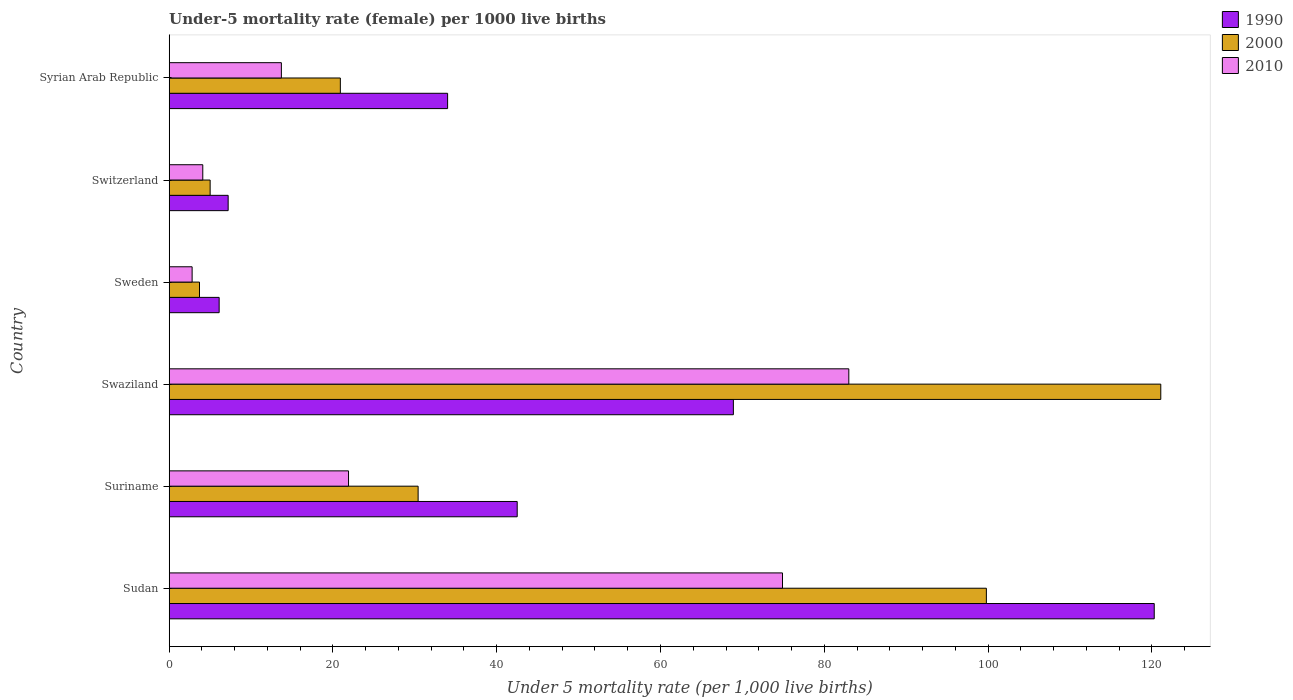How many different coloured bars are there?
Offer a terse response. 3. How many groups of bars are there?
Offer a terse response. 6. Are the number of bars per tick equal to the number of legend labels?
Offer a terse response. Yes. How many bars are there on the 5th tick from the bottom?
Provide a succinct answer. 3. What is the label of the 5th group of bars from the top?
Provide a short and direct response. Suriname. In how many cases, is the number of bars for a given country not equal to the number of legend labels?
Provide a succinct answer. 0. What is the under-five mortality rate in 2000 in Syrian Arab Republic?
Your answer should be very brief. 20.9. Across all countries, what is the maximum under-five mortality rate in 2010?
Offer a very short reply. 83. Across all countries, what is the minimum under-five mortality rate in 2010?
Make the answer very short. 2.8. In which country was the under-five mortality rate in 1990 maximum?
Ensure brevity in your answer.  Sudan. In which country was the under-five mortality rate in 2010 minimum?
Your response must be concise. Sweden. What is the total under-five mortality rate in 2000 in the graph?
Your answer should be compact. 280.9. What is the difference between the under-five mortality rate in 1990 in Sudan and that in Switzerland?
Ensure brevity in your answer.  113.1. What is the difference between the under-five mortality rate in 2000 in Syrian Arab Republic and the under-five mortality rate in 2010 in Swaziland?
Keep it short and to the point. -62.1. What is the average under-five mortality rate in 1990 per country?
Provide a short and direct response. 46.5. What is the difference between the under-five mortality rate in 2010 and under-five mortality rate in 1990 in Swaziland?
Give a very brief answer. 14.1. In how many countries, is the under-five mortality rate in 2010 greater than 12 ?
Your answer should be very brief. 4. What is the ratio of the under-five mortality rate in 1990 in Sweden to that in Syrian Arab Republic?
Ensure brevity in your answer.  0.18. Is the under-five mortality rate in 2010 in Swaziland less than that in Sweden?
Your answer should be very brief. No. Is the difference between the under-five mortality rate in 2010 in Sudan and Sweden greater than the difference between the under-five mortality rate in 1990 in Sudan and Sweden?
Your response must be concise. No. What is the difference between the highest and the second highest under-five mortality rate in 2010?
Provide a short and direct response. 8.1. What is the difference between the highest and the lowest under-five mortality rate in 1990?
Ensure brevity in your answer.  114.2. What does the 1st bar from the top in Sweden represents?
Give a very brief answer. 2010. Are all the bars in the graph horizontal?
Keep it short and to the point. Yes. How many countries are there in the graph?
Your response must be concise. 6. What is the difference between two consecutive major ticks on the X-axis?
Offer a terse response. 20. Does the graph contain grids?
Your answer should be very brief. No. How many legend labels are there?
Offer a terse response. 3. How are the legend labels stacked?
Keep it short and to the point. Vertical. What is the title of the graph?
Give a very brief answer. Under-5 mortality rate (female) per 1000 live births. What is the label or title of the X-axis?
Make the answer very short. Under 5 mortality rate (per 1,0 live births). What is the Under 5 mortality rate (per 1,000 live births) in 1990 in Sudan?
Give a very brief answer. 120.3. What is the Under 5 mortality rate (per 1,000 live births) of 2000 in Sudan?
Provide a short and direct response. 99.8. What is the Under 5 mortality rate (per 1,000 live births) in 2010 in Sudan?
Give a very brief answer. 74.9. What is the Under 5 mortality rate (per 1,000 live births) in 1990 in Suriname?
Keep it short and to the point. 42.5. What is the Under 5 mortality rate (per 1,000 live births) in 2000 in Suriname?
Your answer should be very brief. 30.4. What is the Under 5 mortality rate (per 1,000 live births) of 2010 in Suriname?
Offer a terse response. 21.9. What is the Under 5 mortality rate (per 1,000 live births) in 1990 in Swaziland?
Make the answer very short. 68.9. What is the Under 5 mortality rate (per 1,000 live births) of 2000 in Swaziland?
Your response must be concise. 121.1. What is the Under 5 mortality rate (per 1,000 live births) in 2000 in Sweden?
Ensure brevity in your answer.  3.7. What is the Under 5 mortality rate (per 1,000 live births) of 2010 in Sweden?
Your answer should be compact. 2.8. What is the Under 5 mortality rate (per 1,000 live births) in 2000 in Switzerland?
Offer a very short reply. 5. What is the Under 5 mortality rate (per 1,000 live births) of 2000 in Syrian Arab Republic?
Your answer should be very brief. 20.9. What is the Under 5 mortality rate (per 1,000 live births) of 2010 in Syrian Arab Republic?
Keep it short and to the point. 13.7. Across all countries, what is the maximum Under 5 mortality rate (per 1,000 live births) of 1990?
Offer a very short reply. 120.3. Across all countries, what is the maximum Under 5 mortality rate (per 1,000 live births) of 2000?
Your answer should be compact. 121.1. Across all countries, what is the minimum Under 5 mortality rate (per 1,000 live births) in 1990?
Provide a short and direct response. 6.1. Across all countries, what is the minimum Under 5 mortality rate (per 1,000 live births) in 2000?
Make the answer very short. 3.7. Across all countries, what is the minimum Under 5 mortality rate (per 1,000 live births) of 2010?
Your answer should be compact. 2.8. What is the total Under 5 mortality rate (per 1,000 live births) of 1990 in the graph?
Offer a terse response. 279. What is the total Under 5 mortality rate (per 1,000 live births) in 2000 in the graph?
Your answer should be very brief. 280.9. What is the total Under 5 mortality rate (per 1,000 live births) in 2010 in the graph?
Provide a succinct answer. 200.4. What is the difference between the Under 5 mortality rate (per 1,000 live births) in 1990 in Sudan and that in Suriname?
Offer a terse response. 77.8. What is the difference between the Under 5 mortality rate (per 1,000 live births) in 2000 in Sudan and that in Suriname?
Provide a short and direct response. 69.4. What is the difference between the Under 5 mortality rate (per 1,000 live births) of 2010 in Sudan and that in Suriname?
Provide a succinct answer. 53. What is the difference between the Under 5 mortality rate (per 1,000 live births) in 1990 in Sudan and that in Swaziland?
Provide a short and direct response. 51.4. What is the difference between the Under 5 mortality rate (per 1,000 live births) of 2000 in Sudan and that in Swaziland?
Offer a terse response. -21.3. What is the difference between the Under 5 mortality rate (per 1,000 live births) in 1990 in Sudan and that in Sweden?
Give a very brief answer. 114.2. What is the difference between the Under 5 mortality rate (per 1,000 live births) in 2000 in Sudan and that in Sweden?
Offer a terse response. 96.1. What is the difference between the Under 5 mortality rate (per 1,000 live births) of 2010 in Sudan and that in Sweden?
Your response must be concise. 72.1. What is the difference between the Under 5 mortality rate (per 1,000 live births) of 1990 in Sudan and that in Switzerland?
Provide a succinct answer. 113.1. What is the difference between the Under 5 mortality rate (per 1,000 live births) of 2000 in Sudan and that in Switzerland?
Make the answer very short. 94.8. What is the difference between the Under 5 mortality rate (per 1,000 live births) in 2010 in Sudan and that in Switzerland?
Provide a succinct answer. 70.8. What is the difference between the Under 5 mortality rate (per 1,000 live births) in 1990 in Sudan and that in Syrian Arab Republic?
Ensure brevity in your answer.  86.3. What is the difference between the Under 5 mortality rate (per 1,000 live births) in 2000 in Sudan and that in Syrian Arab Republic?
Your answer should be very brief. 78.9. What is the difference between the Under 5 mortality rate (per 1,000 live births) of 2010 in Sudan and that in Syrian Arab Republic?
Provide a succinct answer. 61.2. What is the difference between the Under 5 mortality rate (per 1,000 live births) in 1990 in Suriname and that in Swaziland?
Provide a succinct answer. -26.4. What is the difference between the Under 5 mortality rate (per 1,000 live births) of 2000 in Suriname and that in Swaziland?
Make the answer very short. -90.7. What is the difference between the Under 5 mortality rate (per 1,000 live births) of 2010 in Suriname and that in Swaziland?
Make the answer very short. -61.1. What is the difference between the Under 5 mortality rate (per 1,000 live births) in 1990 in Suriname and that in Sweden?
Offer a very short reply. 36.4. What is the difference between the Under 5 mortality rate (per 1,000 live births) in 2000 in Suriname and that in Sweden?
Give a very brief answer. 26.7. What is the difference between the Under 5 mortality rate (per 1,000 live births) in 2010 in Suriname and that in Sweden?
Your answer should be compact. 19.1. What is the difference between the Under 5 mortality rate (per 1,000 live births) in 1990 in Suriname and that in Switzerland?
Keep it short and to the point. 35.3. What is the difference between the Under 5 mortality rate (per 1,000 live births) in 2000 in Suriname and that in Switzerland?
Your answer should be compact. 25.4. What is the difference between the Under 5 mortality rate (per 1,000 live births) in 2010 in Suriname and that in Switzerland?
Your response must be concise. 17.8. What is the difference between the Under 5 mortality rate (per 1,000 live births) in 1990 in Suriname and that in Syrian Arab Republic?
Your response must be concise. 8.5. What is the difference between the Under 5 mortality rate (per 1,000 live births) in 2000 in Suriname and that in Syrian Arab Republic?
Your answer should be compact. 9.5. What is the difference between the Under 5 mortality rate (per 1,000 live births) of 2010 in Suriname and that in Syrian Arab Republic?
Make the answer very short. 8.2. What is the difference between the Under 5 mortality rate (per 1,000 live births) of 1990 in Swaziland and that in Sweden?
Give a very brief answer. 62.8. What is the difference between the Under 5 mortality rate (per 1,000 live births) of 2000 in Swaziland and that in Sweden?
Your answer should be very brief. 117.4. What is the difference between the Under 5 mortality rate (per 1,000 live births) of 2010 in Swaziland and that in Sweden?
Your response must be concise. 80.2. What is the difference between the Under 5 mortality rate (per 1,000 live births) in 1990 in Swaziland and that in Switzerland?
Your response must be concise. 61.7. What is the difference between the Under 5 mortality rate (per 1,000 live births) in 2000 in Swaziland and that in Switzerland?
Give a very brief answer. 116.1. What is the difference between the Under 5 mortality rate (per 1,000 live births) in 2010 in Swaziland and that in Switzerland?
Give a very brief answer. 78.9. What is the difference between the Under 5 mortality rate (per 1,000 live births) of 1990 in Swaziland and that in Syrian Arab Republic?
Your answer should be compact. 34.9. What is the difference between the Under 5 mortality rate (per 1,000 live births) in 2000 in Swaziland and that in Syrian Arab Republic?
Offer a very short reply. 100.2. What is the difference between the Under 5 mortality rate (per 1,000 live births) in 2010 in Swaziland and that in Syrian Arab Republic?
Keep it short and to the point. 69.3. What is the difference between the Under 5 mortality rate (per 1,000 live births) in 1990 in Sweden and that in Syrian Arab Republic?
Your response must be concise. -27.9. What is the difference between the Under 5 mortality rate (per 1,000 live births) in 2000 in Sweden and that in Syrian Arab Republic?
Give a very brief answer. -17.2. What is the difference between the Under 5 mortality rate (per 1,000 live births) of 2010 in Sweden and that in Syrian Arab Republic?
Your answer should be compact. -10.9. What is the difference between the Under 5 mortality rate (per 1,000 live births) in 1990 in Switzerland and that in Syrian Arab Republic?
Your response must be concise. -26.8. What is the difference between the Under 5 mortality rate (per 1,000 live births) in 2000 in Switzerland and that in Syrian Arab Republic?
Offer a terse response. -15.9. What is the difference between the Under 5 mortality rate (per 1,000 live births) of 2010 in Switzerland and that in Syrian Arab Republic?
Your response must be concise. -9.6. What is the difference between the Under 5 mortality rate (per 1,000 live births) of 1990 in Sudan and the Under 5 mortality rate (per 1,000 live births) of 2000 in Suriname?
Offer a very short reply. 89.9. What is the difference between the Under 5 mortality rate (per 1,000 live births) in 1990 in Sudan and the Under 5 mortality rate (per 1,000 live births) in 2010 in Suriname?
Make the answer very short. 98.4. What is the difference between the Under 5 mortality rate (per 1,000 live births) of 2000 in Sudan and the Under 5 mortality rate (per 1,000 live births) of 2010 in Suriname?
Keep it short and to the point. 77.9. What is the difference between the Under 5 mortality rate (per 1,000 live births) in 1990 in Sudan and the Under 5 mortality rate (per 1,000 live births) in 2000 in Swaziland?
Your answer should be compact. -0.8. What is the difference between the Under 5 mortality rate (per 1,000 live births) in 1990 in Sudan and the Under 5 mortality rate (per 1,000 live births) in 2010 in Swaziland?
Provide a short and direct response. 37.3. What is the difference between the Under 5 mortality rate (per 1,000 live births) in 1990 in Sudan and the Under 5 mortality rate (per 1,000 live births) in 2000 in Sweden?
Your answer should be compact. 116.6. What is the difference between the Under 5 mortality rate (per 1,000 live births) in 1990 in Sudan and the Under 5 mortality rate (per 1,000 live births) in 2010 in Sweden?
Give a very brief answer. 117.5. What is the difference between the Under 5 mortality rate (per 1,000 live births) in 2000 in Sudan and the Under 5 mortality rate (per 1,000 live births) in 2010 in Sweden?
Give a very brief answer. 97. What is the difference between the Under 5 mortality rate (per 1,000 live births) of 1990 in Sudan and the Under 5 mortality rate (per 1,000 live births) of 2000 in Switzerland?
Provide a short and direct response. 115.3. What is the difference between the Under 5 mortality rate (per 1,000 live births) in 1990 in Sudan and the Under 5 mortality rate (per 1,000 live births) in 2010 in Switzerland?
Provide a short and direct response. 116.2. What is the difference between the Under 5 mortality rate (per 1,000 live births) in 2000 in Sudan and the Under 5 mortality rate (per 1,000 live births) in 2010 in Switzerland?
Your answer should be very brief. 95.7. What is the difference between the Under 5 mortality rate (per 1,000 live births) in 1990 in Sudan and the Under 5 mortality rate (per 1,000 live births) in 2000 in Syrian Arab Republic?
Your answer should be compact. 99.4. What is the difference between the Under 5 mortality rate (per 1,000 live births) in 1990 in Sudan and the Under 5 mortality rate (per 1,000 live births) in 2010 in Syrian Arab Republic?
Your answer should be compact. 106.6. What is the difference between the Under 5 mortality rate (per 1,000 live births) of 2000 in Sudan and the Under 5 mortality rate (per 1,000 live births) of 2010 in Syrian Arab Republic?
Your response must be concise. 86.1. What is the difference between the Under 5 mortality rate (per 1,000 live births) of 1990 in Suriname and the Under 5 mortality rate (per 1,000 live births) of 2000 in Swaziland?
Your response must be concise. -78.6. What is the difference between the Under 5 mortality rate (per 1,000 live births) in 1990 in Suriname and the Under 5 mortality rate (per 1,000 live births) in 2010 in Swaziland?
Give a very brief answer. -40.5. What is the difference between the Under 5 mortality rate (per 1,000 live births) of 2000 in Suriname and the Under 5 mortality rate (per 1,000 live births) of 2010 in Swaziland?
Make the answer very short. -52.6. What is the difference between the Under 5 mortality rate (per 1,000 live births) in 1990 in Suriname and the Under 5 mortality rate (per 1,000 live births) in 2000 in Sweden?
Offer a terse response. 38.8. What is the difference between the Under 5 mortality rate (per 1,000 live births) in 1990 in Suriname and the Under 5 mortality rate (per 1,000 live births) in 2010 in Sweden?
Offer a terse response. 39.7. What is the difference between the Under 5 mortality rate (per 1,000 live births) of 2000 in Suriname and the Under 5 mortality rate (per 1,000 live births) of 2010 in Sweden?
Offer a terse response. 27.6. What is the difference between the Under 5 mortality rate (per 1,000 live births) of 1990 in Suriname and the Under 5 mortality rate (per 1,000 live births) of 2000 in Switzerland?
Provide a succinct answer. 37.5. What is the difference between the Under 5 mortality rate (per 1,000 live births) of 1990 in Suriname and the Under 5 mortality rate (per 1,000 live births) of 2010 in Switzerland?
Ensure brevity in your answer.  38.4. What is the difference between the Under 5 mortality rate (per 1,000 live births) in 2000 in Suriname and the Under 5 mortality rate (per 1,000 live births) in 2010 in Switzerland?
Keep it short and to the point. 26.3. What is the difference between the Under 5 mortality rate (per 1,000 live births) in 1990 in Suriname and the Under 5 mortality rate (per 1,000 live births) in 2000 in Syrian Arab Republic?
Provide a short and direct response. 21.6. What is the difference between the Under 5 mortality rate (per 1,000 live births) of 1990 in Suriname and the Under 5 mortality rate (per 1,000 live births) of 2010 in Syrian Arab Republic?
Your answer should be compact. 28.8. What is the difference between the Under 5 mortality rate (per 1,000 live births) in 2000 in Suriname and the Under 5 mortality rate (per 1,000 live births) in 2010 in Syrian Arab Republic?
Your answer should be very brief. 16.7. What is the difference between the Under 5 mortality rate (per 1,000 live births) in 1990 in Swaziland and the Under 5 mortality rate (per 1,000 live births) in 2000 in Sweden?
Provide a short and direct response. 65.2. What is the difference between the Under 5 mortality rate (per 1,000 live births) of 1990 in Swaziland and the Under 5 mortality rate (per 1,000 live births) of 2010 in Sweden?
Provide a short and direct response. 66.1. What is the difference between the Under 5 mortality rate (per 1,000 live births) in 2000 in Swaziland and the Under 5 mortality rate (per 1,000 live births) in 2010 in Sweden?
Your response must be concise. 118.3. What is the difference between the Under 5 mortality rate (per 1,000 live births) in 1990 in Swaziland and the Under 5 mortality rate (per 1,000 live births) in 2000 in Switzerland?
Provide a succinct answer. 63.9. What is the difference between the Under 5 mortality rate (per 1,000 live births) in 1990 in Swaziland and the Under 5 mortality rate (per 1,000 live births) in 2010 in Switzerland?
Provide a short and direct response. 64.8. What is the difference between the Under 5 mortality rate (per 1,000 live births) in 2000 in Swaziland and the Under 5 mortality rate (per 1,000 live births) in 2010 in Switzerland?
Keep it short and to the point. 117. What is the difference between the Under 5 mortality rate (per 1,000 live births) of 1990 in Swaziland and the Under 5 mortality rate (per 1,000 live births) of 2010 in Syrian Arab Republic?
Offer a terse response. 55.2. What is the difference between the Under 5 mortality rate (per 1,000 live births) in 2000 in Swaziland and the Under 5 mortality rate (per 1,000 live births) in 2010 in Syrian Arab Republic?
Provide a succinct answer. 107.4. What is the difference between the Under 5 mortality rate (per 1,000 live births) of 1990 in Sweden and the Under 5 mortality rate (per 1,000 live births) of 2000 in Switzerland?
Provide a short and direct response. 1.1. What is the difference between the Under 5 mortality rate (per 1,000 live births) in 2000 in Sweden and the Under 5 mortality rate (per 1,000 live births) in 2010 in Switzerland?
Offer a terse response. -0.4. What is the difference between the Under 5 mortality rate (per 1,000 live births) in 1990 in Sweden and the Under 5 mortality rate (per 1,000 live births) in 2000 in Syrian Arab Republic?
Your answer should be compact. -14.8. What is the difference between the Under 5 mortality rate (per 1,000 live births) of 2000 in Sweden and the Under 5 mortality rate (per 1,000 live births) of 2010 in Syrian Arab Republic?
Keep it short and to the point. -10. What is the difference between the Under 5 mortality rate (per 1,000 live births) in 1990 in Switzerland and the Under 5 mortality rate (per 1,000 live births) in 2000 in Syrian Arab Republic?
Provide a short and direct response. -13.7. What is the difference between the Under 5 mortality rate (per 1,000 live births) of 2000 in Switzerland and the Under 5 mortality rate (per 1,000 live births) of 2010 in Syrian Arab Republic?
Provide a short and direct response. -8.7. What is the average Under 5 mortality rate (per 1,000 live births) of 1990 per country?
Offer a terse response. 46.5. What is the average Under 5 mortality rate (per 1,000 live births) of 2000 per country?
Provide a succinct answer. 46.82. What is the average Under 5 mortality rate (per 1,000 live births) of 2010 per country?
Offer a very short reply. 33.4. What is the difference between the Under 5 mortality rate (per 1,000 live births) of 1990 and Under 5 mortality rate (per 1,000 live births) of 2000 in Sudan?
Make the answer very short. 20.5. What is the difference between the Under 5 mortality rate (per 1,000 live births) in 1990 and Under 5 mortality rate (per 1,000 live births) in 2010 in Sudan?
Keep it short and to the point. 45.4. What is the difference between the Under 5 mortality rate (per 1,000 live births) in 2000 and Under 5 mortality rate (per 1,000 live births) in 2010 in Sudan?
Your response must be concise. 24.9. What is the difference between the Under 5 mortality rate (per 1,000 live births) in 1990 and Under 5 mortality rate (per 1,000 live births) in 2000 in Suriname?
Provide a short and direct response. 12.1. What is the difference between the Under 5 mortality rate (per 1,000 live births) in 1990 and Under 5 mortality rate (per 1,000 live births) in 2010 in Suriname?
Make the answer very short. 20.6. What is the difference between the Under 5 mortality rate (per 1,000 live births) in 2000 and Under 5 mortality rate (per 1,000 live births) in 2010 in Suriname?
Your response must be concise. 8.5. What is the difference between the Under 5 mortality rate (per 1,000 live births) of 1990 and Under 5 mortality rate (per 1,000 live births) of 2000 in Swaziland?
Your response must be concise. -52.2. What is the difference between the Under 5 mortality rate (per 1,000 live births) of 1990 and Under 5 mortality rate (per 1,000 live births) of 2010 in Swaziland?
Provide a succinct answer. -14.1. What is the difference between the Under 5 mortality rate (per 1,000 live births) of 2000 and Under 5 mortality rate (per 1,000 live births) of 2010 in Swaziland?
Offer a very short reply. 38.1. What is the difference between the Under 5 mortality rate (per 1,000 live births) of 1990 and Under 5 mortality rate (per 1,000 live births) of 2010 in Sweden?
Ensure brevity in your answer.  3.3. What is the difference between the Under 5 mortality rate (per 1,000 live births) of 2000 and Under 5 mortality rate (per 1,000 live births) of 2010 in Sweden?
Provide a succinct answer. 0.9. What is the difference between the Under 5 mortality rate (per 1,000 live births) in 1990 and Under 5 mortality rate (per 1,000 live births) in 2010 in Syrian Arab Republic?
Ensure brevity in your answer.  20.3. What is the difference between the Under 5 mortality rate (per 1,000 live births) in 2000 and Under 5 mortality rate (per 1,000 live births) in 2010 in Syrian Arab Republic?
Provide a succinct answer. 7.2. What is the ratio of the Under 5 mortality rate (per 1,000 live births) of 1990 in Sudan to that in Suriname?
Your response must be concise. 2.83. What is the ratio of the Under 5 mortality rate (per 1,000 live births) of 2000 in Sudan to that in Suriname?
Your answer should be very brief. 3.28. What is the ratio of the Under 5 mortality rate (per 1,000 live births) in 2010 in Sudan to that in Suriname?
Your answer should be very brief. 3.42. What is the ratio of the Under 5 mortality rate (per 1,000 live births) of 1990 in Sudan to that in Swaziland?
Your answer should be very brief. 1.75. What is the ratio of the Under 5 mortality rate (per 1,000 live births) in 2000 in Sudan to that in Swaziland?
Give a very brief answer. 0.82. What is the ratio of the Under 5 mortality rate (per 1,000 live births) in 2010 in Sudan to that in Swaziland?
Give a very brief answer. 0.9. What is the ratio of the Under 5 mortality rate (per 1,000 live births) in 1990 in Sudan to that in Sweden?
Keep it short and to the point. 19.72. What is the ratio of the Under 5 mortality rate (per 1,000 live births) in 2000 in Sudan to that in Sweden?
Your answer should be compact. 26.97. What is the ratio of the Under 5 mortality rate (per 1,000 live births) of 2010 in Sudan to that in Sweden?
Ensure brevity in your answer.  26.75. What is the ratio of the Under 5 mortality rate (per 1,000 live births) in 1990 in Sudan to that in Switzerland?
Your response must be concise. 16.71. What is the ratio of the Under 5 mortality rate (per 1,000 live births) of 2000 in Sudan to that in Switzerland?
Offer a terse response. 19.96. What is the ratio of the Under 5 mortality rate (per 1,000 live births) of 2010 in Sudan to that in Switzerland?
Offer a terse response. 18.27. What is the ratio of the Under 5 mortality rate (per 1,000 live births) in 1990 in Sudan to that in Syrian Arab Republic?
Your answer should be very brief. 3.54. What is the ratio of the Under 5 mortality rate (per 1,000 live births) of 2000 in Sudan to that in Syrian Arab Republic?
Make the answer very short. 4.78. What is the ratio of the Under 5 mortality rate (per 1,000 live births) in 2010 in Sudan to that in Syrian Arab Republic?
Provide a short and direct response. 5.47. What is the ratio of the Under 5 mortality rate (per 1,000 live births) of 1990 in Suriname to that in Swaziland?
Your response must be concise. 0.62. What is the ratio of the Under 5 mortality rate (per 1,000 live births) of 2000 in Suriname to that in Swaziland?
Provide a short and direct response. 0.25. What is the ratio of the Under 5 mortality rate (per 1,000 live births) of 2010 in Suriname to that in Swaziland?
Provide a succinct answer. 0.26. What is the ratio of the Under 5 mortality rate (per 1,000 live births) in 1990 in Suriname to that in Sweden?
Your response must be concise. 6.97. What is the ratio of the Under 5 mortality rate (per 1,000 live births) of 2000 in Suriname to that in Sweden?
Your answer should be compact. 8.22. What is the ratio of the Under 5 mortality rate (per 1,000 live births) in 2010 in Suriname to that in Sweden?
Keep it short and to the point. 7.82. What is the ratio of the Under 5 mortality rate (per 1,000 live births) of 1990 in Suriname to that in Switzerland?
Your response must be concise. 5.9. What is the ratio of the Under 5 mortality rate (per 1,000 live births) of 2000 in Suriname to that in Switzerland?
Offer a terse response. 6.08. What is the ratio of the Under 5 mortality rate (per 1,000 live births) of 2010 in Suriname to that in Switzerland?
Your response must be concise. 5.34. What is the ratio of the Under 5 mortality rate (per 1,000 live births) in 2000 in Suriname to that in Syrian Arab Republic?
Offer a very short reply. 1.45. What is the ratio of the Under 5 mortality rate (per 1,000 live births) in 2010 in Suriname to that in Syrian Arab Republic?
Provide a short and direct response. 1.6. What is the ratio of the Under 5 mortality rate (per 1,000 live births) in 1990 in Swaziland to that in Sweden?
Provide a succinct answer. 11.3. What is the ratio of the Under 5 mortality rate (per 1,000 live births) of 2000 in Swaziland to that in Sweden?
Offer a terse response. 32.73. What is the ratio of the Under 5 mortality rate (per 1,000 live births) of 2010 in Swaziland to that in Sweden?
Your answer should be compact. 29.64. What is the ratio of the Under 5 mortality rate (per 1,000 live births) of 1990 in Swaziland to that in Switzerland?
Your answer should be compact. 9.57. What is the ratio of the Under 5 mortality rate (per 1,000 live births) of 2000 in Swaziland to that in Switzerland?
Give a very brief answer. 24.22. What is the ratio of the Under 5 mortality rate (per 1,000 live births) in 2010 in Swaziland to that in Switzerland?
Your response must be concise. 20.24. What is the ratio of the Under 5 mortality rate (per 1,000 live births) in 1990 in Swaziland to that in Syrian Arab Republic?
Keep it short and to the point. 2.03. What is the ratio of the Under 5 mortality rate (per 1,000 live births) in 2000 in Swaziland to that in Syrian Arab Republic?
Your answer should be very brief. 5.79. What is the ratio of the Under 5 mortality rate (per 1,000 live births) of 2010 in Swaziland to that in Syrian Arab Republic?
Your answer should be compact. 6.06. What is the ratio of the Under 5 mortality rate (per 1,000 live births) of 1990 in Sweden to that in Switzerland?
Offer a very short reply. 0.85. What is the ratio of the Under 5 mortality rate (per 1,000 live births) in 2000 in Sweden to that in Switzerland?
Your answer should be compact. 0.74. What is the ratio of the Under 5 mortality rate (per 1,000 live births) in 2010 in Sweden to that in Switzerland?
Provide a succinct answer. 0.68. What is the ratio of the Under 5 mortality rate (per 1,000 live births) of 1990 in Sweden to that in Syrian Arab Republic?
Ensure brevity in your answer.  0.18. What is the ratio of the Under 5 mortality rate (per 1,000 live births) in 2000 in Sweden to that in Syrian Arab Republic?
Give a very brief answer. 0.18. What is the ratio of the Under 5 mortality rate (per 1,000 live births) of 2010 in Sweden to that in Syrian Arab Republic?
Provide a short and direct response. 0.2. What is the ratio of the Under 5 mortality rate (per 1,000 live births) of 1990 in Switzerland to that in Syrian Arab Republic?
Your answer should be very brief. 0.21. What is the ratio of the Under 5 mortality rate (per 1,000 live births) of 2000 in Switzerland to that in Syrian Arab Republic?
Provide a succinct answer. 0.24. What is the ratio of the Under 5 mortality rate (per 1,000 live births) in 2010 in Switzerland to that in Syrian Arab Republic?
Provide a short and direct response. 0.3. What is the difference between the highest and the second highest Under 5 mortality rate (per 1,000 live births) of 1990?
Give a very brief answer. 51.4. What is the difference between the highest and the second highest Under 5 mortality rate (per 1,000 live births) in 2000?
Keep it short and to the point. 21.3. What is the difference between the highest and the lowest Under 5 mortality rate (per 1,000 live births) in 1990?
Provide a short and direct response. 114.2. What is the difference between the highest and the lowest Under 5 mortality rate (per 1,000 live births) of 2000?
Make the answer very short. 117.4. What is the difference between the highest and the lowest Under 5 mortality rate (per 1,000 live births) in 2010?
Make the answer very short. 80.2. 